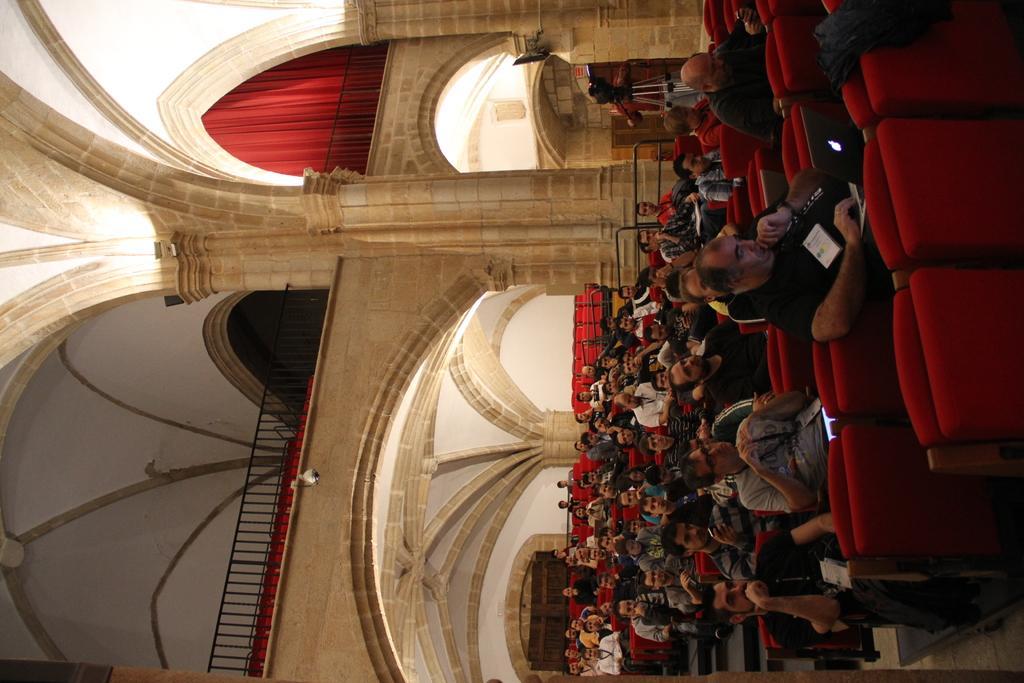Could you give a brief overview of what you see in this image? This picture shows a few people seated on the chairs and we see a human holding a camera and we see red curtain. 